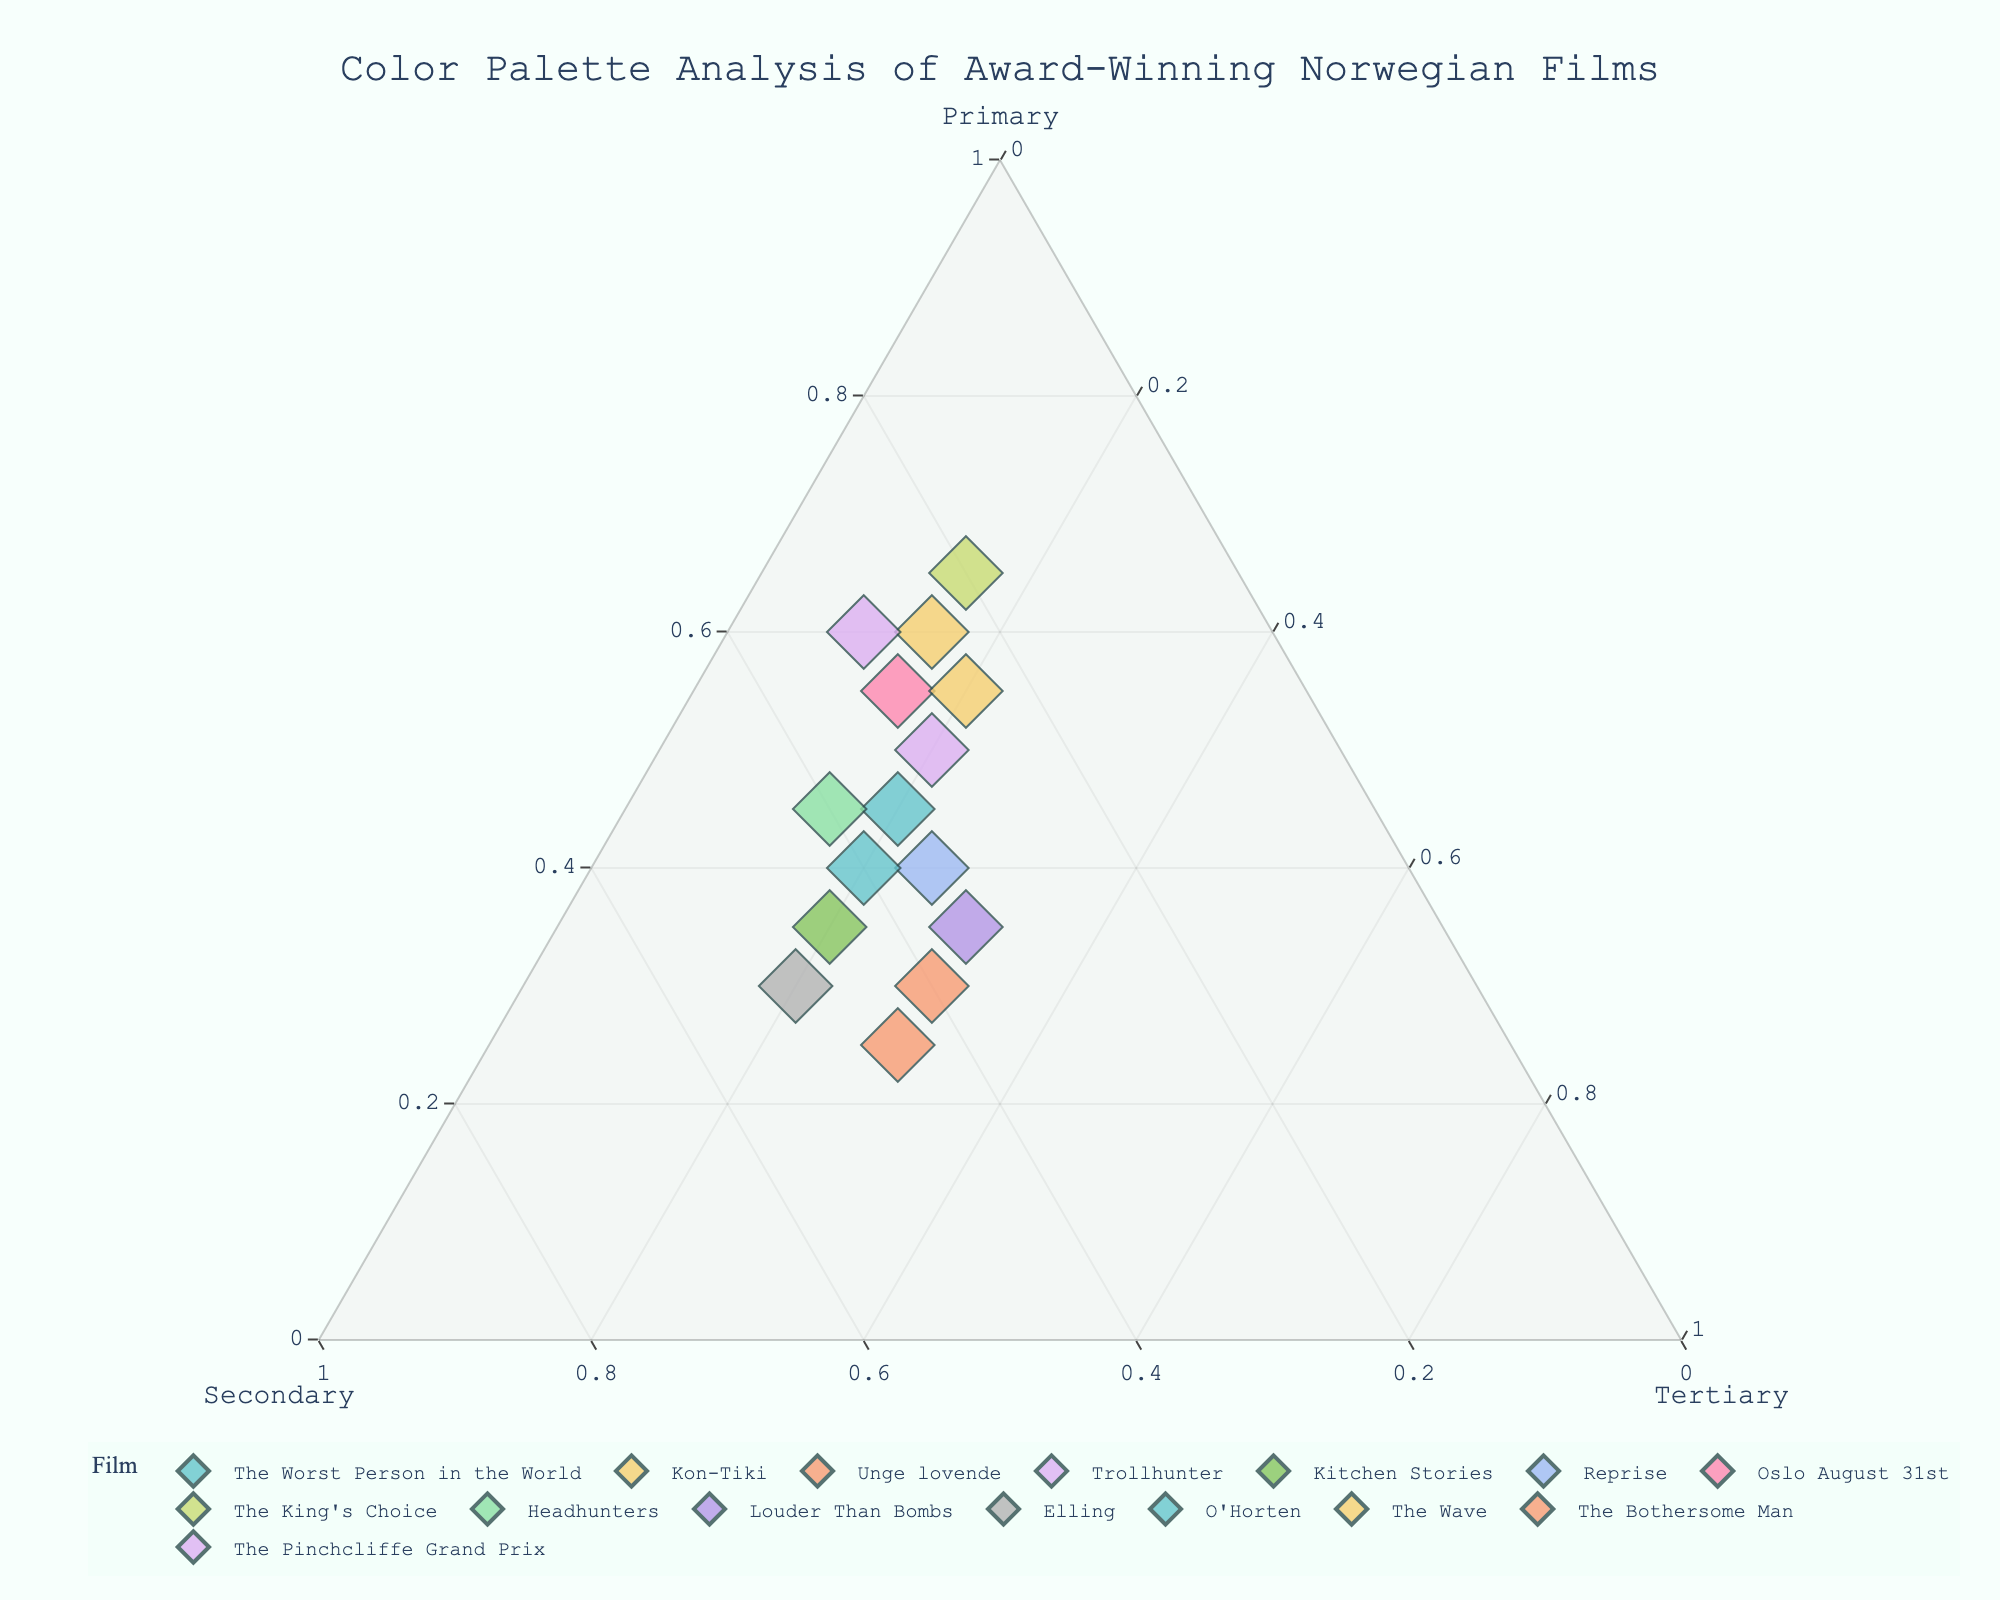What is the title of the ternary plot? The title of the ternary plot can be found at the top of the figure.
Answer: Color Palette Analysis of Award-Winning Norwegian Films Which film has the highest percentage of primary colors? By looking at the axis labeled "Primary," we can see that "The King's Choice" has the highest value near the Primary vertex.
Answer: The King's Choice How many films have primary colors making up at least 50% of their palette? Check the labels near the Primary axis. The films "The King's Choice," "Kon-Tiki," "Oslo August 31st," "Trollhunter," "The Wave," and "The Pinchcliffe Grand Prix" all have primary percentages of at least 50%.
Answer: 6 Between "Trollhunter" and "Kitchen Stories," which film has a higher percentage of secondary colors? Locate both films on the plot and check their positions relative to the Secondary vertex. "Kitchen Stories" is closer to the Secondary axis than "Trollhunter."
Answer: Kitchen Stories What is the sum of secondary and tertiary colors for "Unge lovende"? Find "Unge lovende" on the plot, sum the Secondary (40%) and Tertiary (30%) percentages.
Answer: 70% Which film has the lowest percentage of tertiary colors? By looking towards the Tertiary vertex, spot the film farthest away from this vertex. "The Pinchcliffe Grand Prix" is the farthest.
Answer: The Pinchcliffe Grand Prix Which film has a more balanced palette among primary, secondary, and tertiary colors: "O'Horten" or "Louder Than Bombs"? Compare the position of "O'Horten" and "Louder Than Bombs" on the plot in relation to all three vertices. Noting that "O'Horten" with percentages 40%, 40%, and 20% is more evenly distributed across colors than "Louder Than Bombs" with 35%, 35%, and 30%.
Answer: O'Horten Which axis shows the smallest range of percentage values? Compare the ranges of values along the Primary, Secondary, and Tertiary axes, considering the data points' distributions.
Answer: Tertiary If we consider primary colors' dominance, which film, "The Bothersome Man" or "Headhunters," shows higher values? Compare the positions of "The Bothersome Man" and "Headhunters" along the Primary axis. "Headhunters" is closer to the Primary vertex than "The Bothersome Man."
Answer: Headhunters Which film has the least divergence from equal distribution (33%, 33%, 33%) among the three color categories? Locate the point closest to the centroid of the ternary plot. "Unge lovende" positioned closest to the centroid with values 30%, 40%, and 30% demonstrates the least divergence.
Answer: Unge lovende 